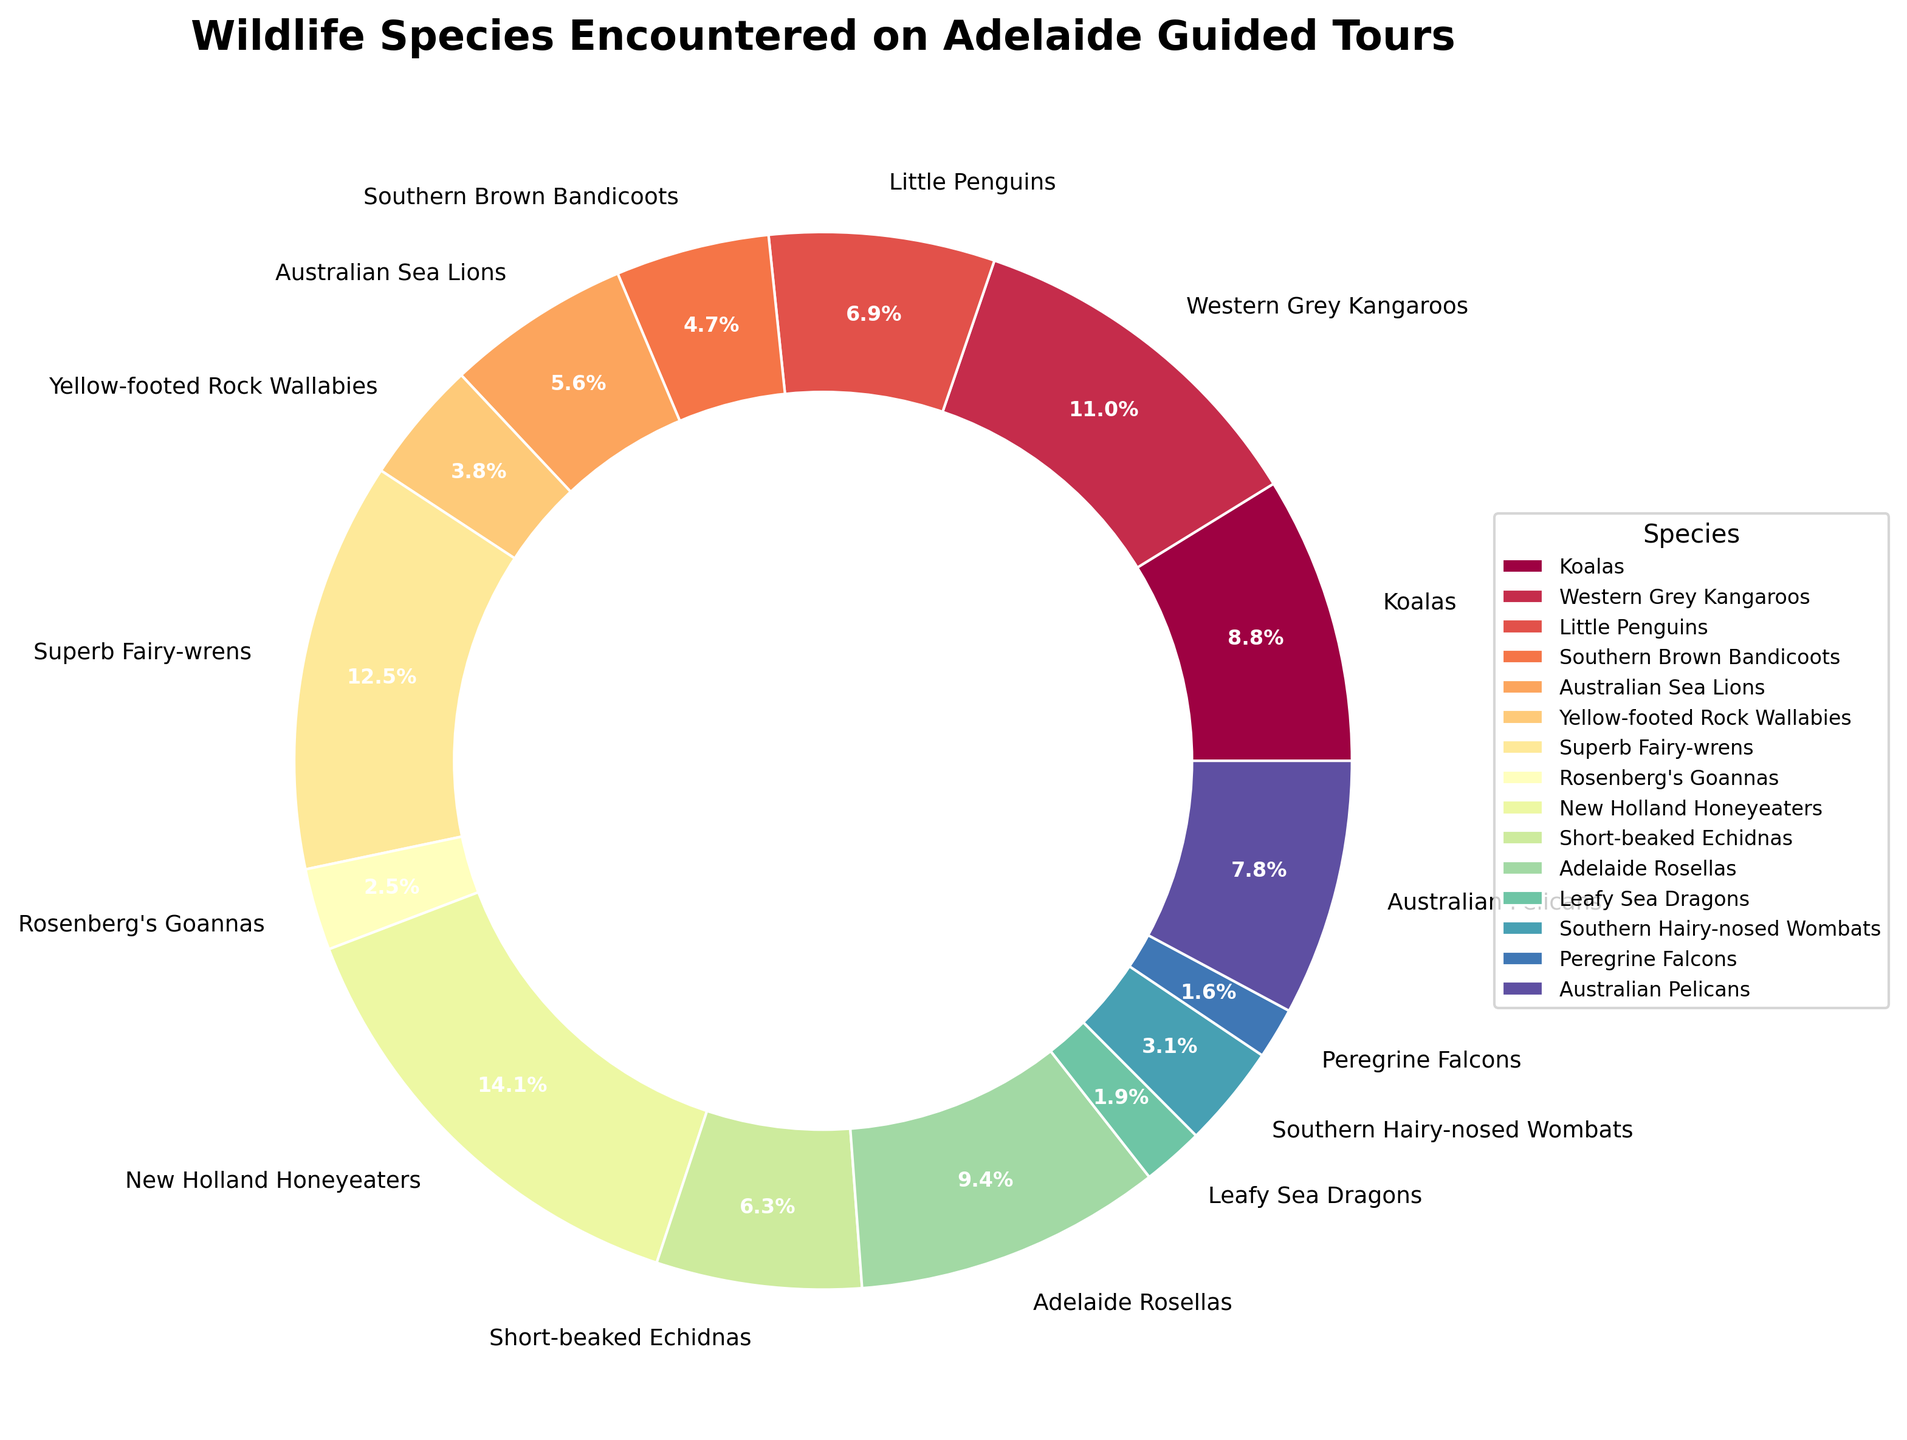Which species had the highest percentage of encounters? Identify the species label with the largest segment in the pie chart. This segment will have the highest percentage value.
Answer: New Holland Honeyeaters Which two species combined have more encounters than Koalas? Look for two species whose combined encounter values are greater than Koalas (28). For instance, Southern Brown Bandicoots (15) and Short-beaked Echidnas (20) sum to 35, which is more than 28.
Answer: Southern Brown Bandicoots and Short-beaked Echidnas How many more encounters were there with Adelaide Rosellas compared to Rosenberg's Goannas? Subtract the encounters of Rosenberg's Goannas (8) from the encounters of Adelaide Rosellas (30). 30 - 8 = 22.
Answer: 22 What is the percentage difference between encounters with Yellow-footed Rock Wallabies and Leafy Sea Dragons? Calculate the percentage of total encounters for each species (Total encounters = 349). Yellow-footed Rock Wallabies = (12/349)*100 ≈ 3.4%, Leafy Sea Dragons = (6/349)*100 ≈ 1.7%. Percentage difference: 3.4% - 1.7% = 1.7%.
Answer: 1.7% Which species is represented by the darkest color segment in the pie chart? Identify the species with a segment color that appears darkest. Usually, the first or last color in the gradient is the darkest.
Answer: Peregrine Falcons How does the percentage of encounters with Australian Sea Lions compare to Australian Pelicans? Calculate their percentages: Australian Sea Lions = (18/349)≈ 5.2%, Australian Pelicans = (25/349)≈ 7.2%. Compare the values: Australian Pelicans > Australian Sea Lions.
Answer: Australian Pelicans have a higher percentage If you grouped all marsupials together, how many total encounters would that be? Sum the encounters of Koalas (28), Western Grey Kangaroos (35), Southern Brown Bandicoots (15), and Southern Hairy-nosed Wombats (10). 28 + 35 + 15 + 10 = 88.
Answer: 88 What proportion of the total encounters involved birds? Identify bird species and their encounters: Little Penguins (22), New Holland Honeyeaters (45), Superb Fairy-wrens (40), Adelaide Rosellas (30), and Australian Pelicans (25). Sum: 22 + 45 + 40 + 30 + 25 = 162. Proportion: 162/349 ≈ 46.4%.
Answer: 46.4% Which species had fewer encounters than Southern Hairy-nosed Wombats? Identify species with encounters less than 10: Rosenberg's Goannas (8), Leafy Sea Dragons (6), Peregrine Falcons (5).
Answer: Rosenberg's Goannas, Leafy Sea Dragons, Peregrine Falcons Of the species listed, which had the least and how many encounters did they have? Identify the segment with the smallest percentage label.
Answer: Peregrine Falcons, 5 